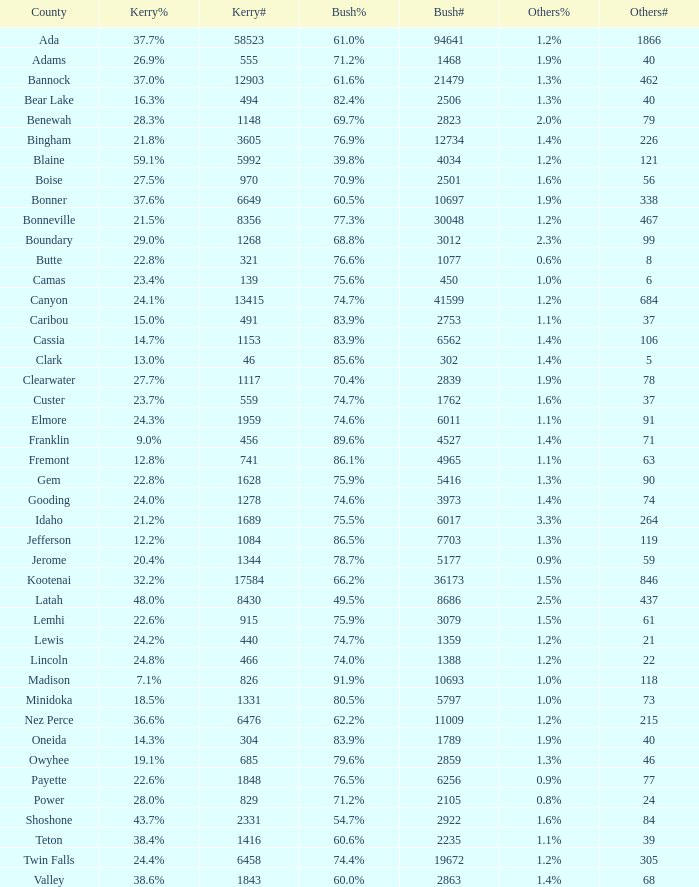What percentage of votes did bush receive in the county where kerry secured 37.6%? 60.5%. 